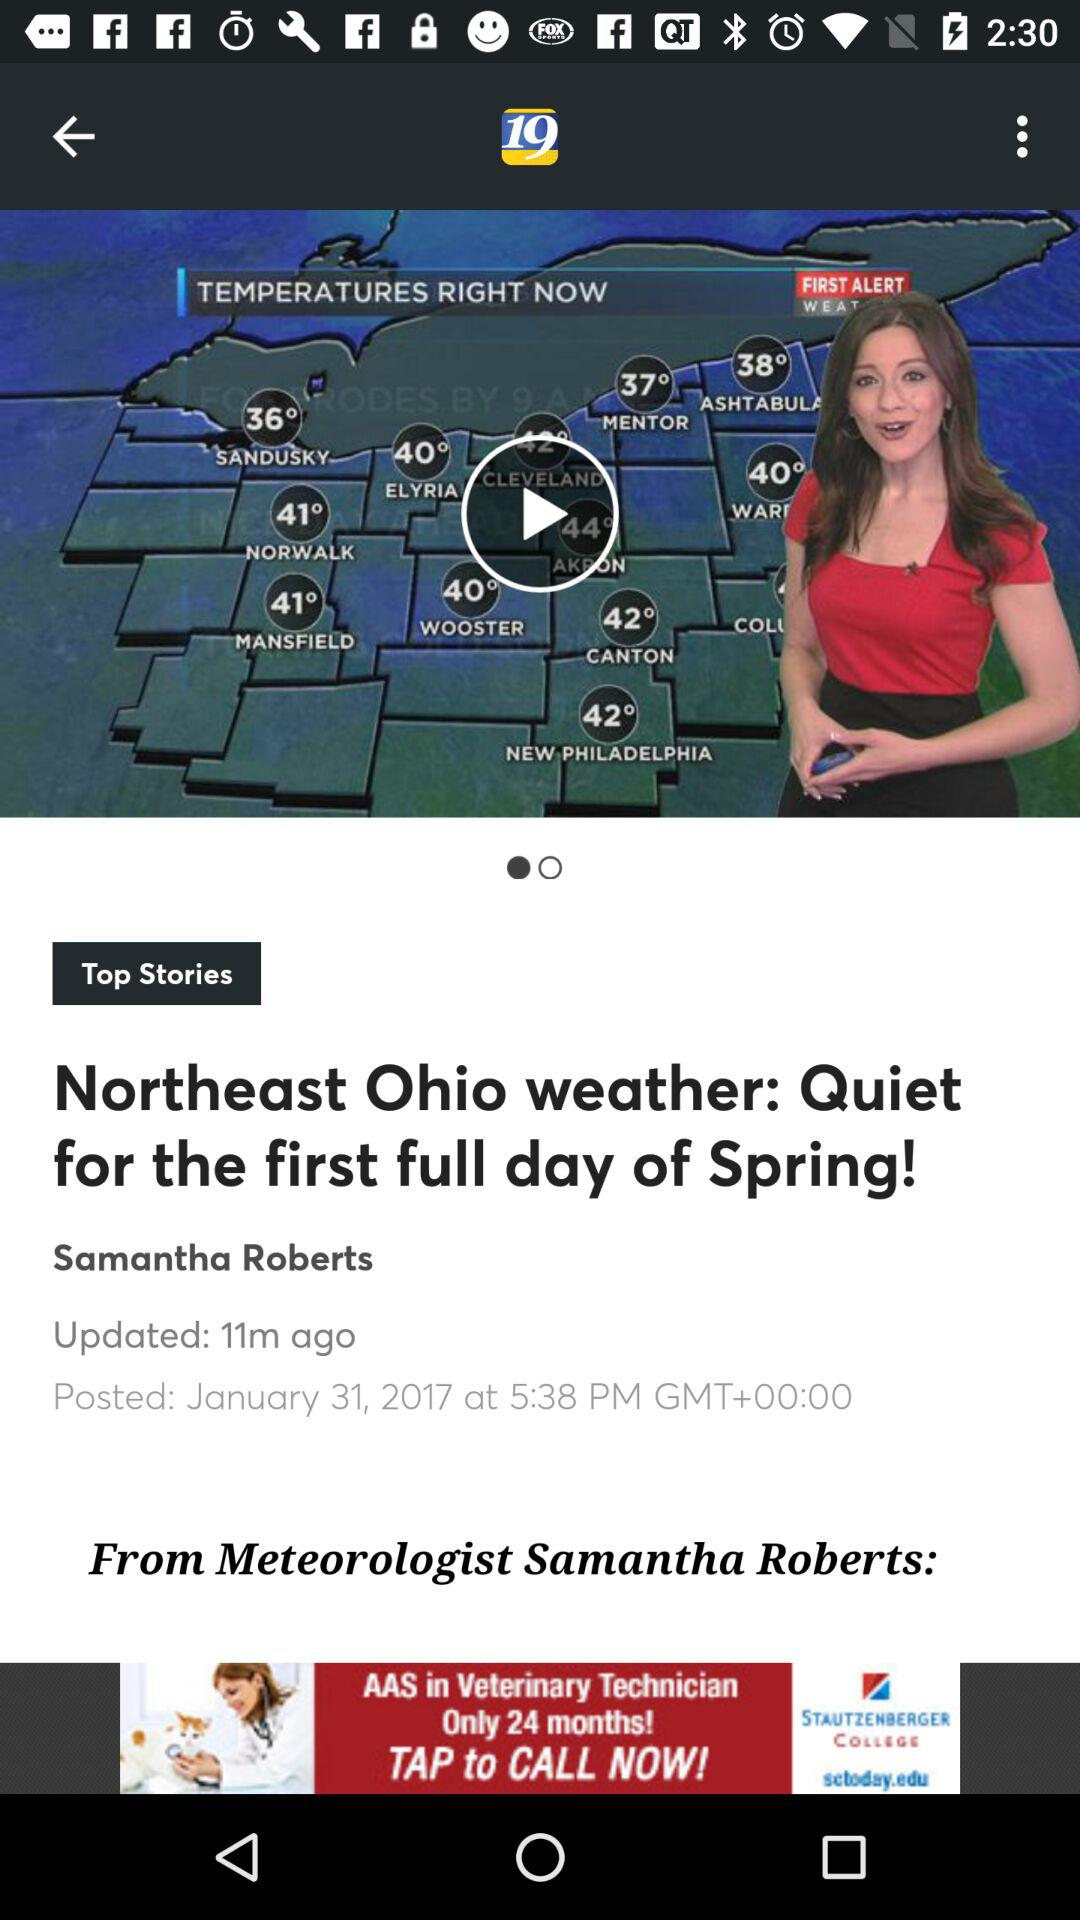What date was the story "Northeast Ohio weather" posted? The date was January 31, 2017. 